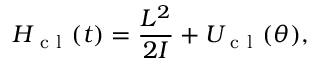Convert formula to latex. <formula><loc_0><loc_0><loc_500><loc_500>H _ { c l } ( t ) = \frac { L ^ { 2 } } { 2 I } + U _ { c l } ( \theta ) ,</formula> 